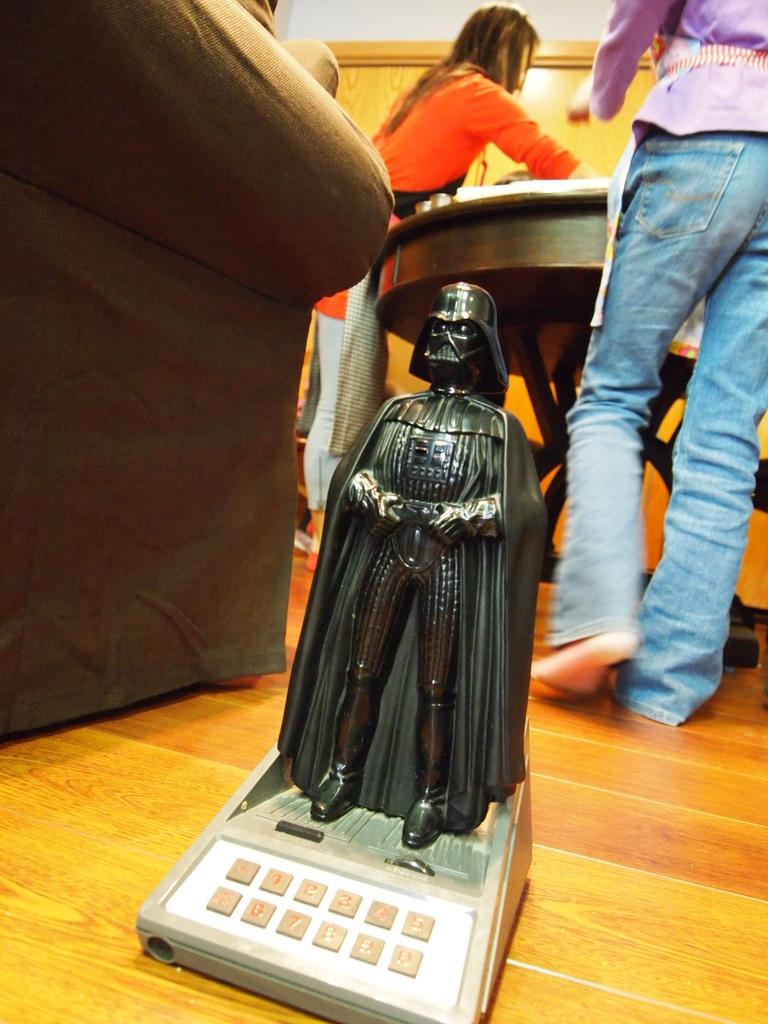What is on the floor in the image? There is a toy on the floor in the image. What are the two people doing in the image? The two people are standing in front of a table in the image. What piece of furniture is on the left side of the image? There is a sofa on the left side of the image. What shape is the parcel that the people are holding in the image? There is no parcel present in the image, and therefore no shape can be determined. How much power is being generated by the toy on the floor in the image? The toy on the floor is not generating any power, as it is a non-electrical object. 